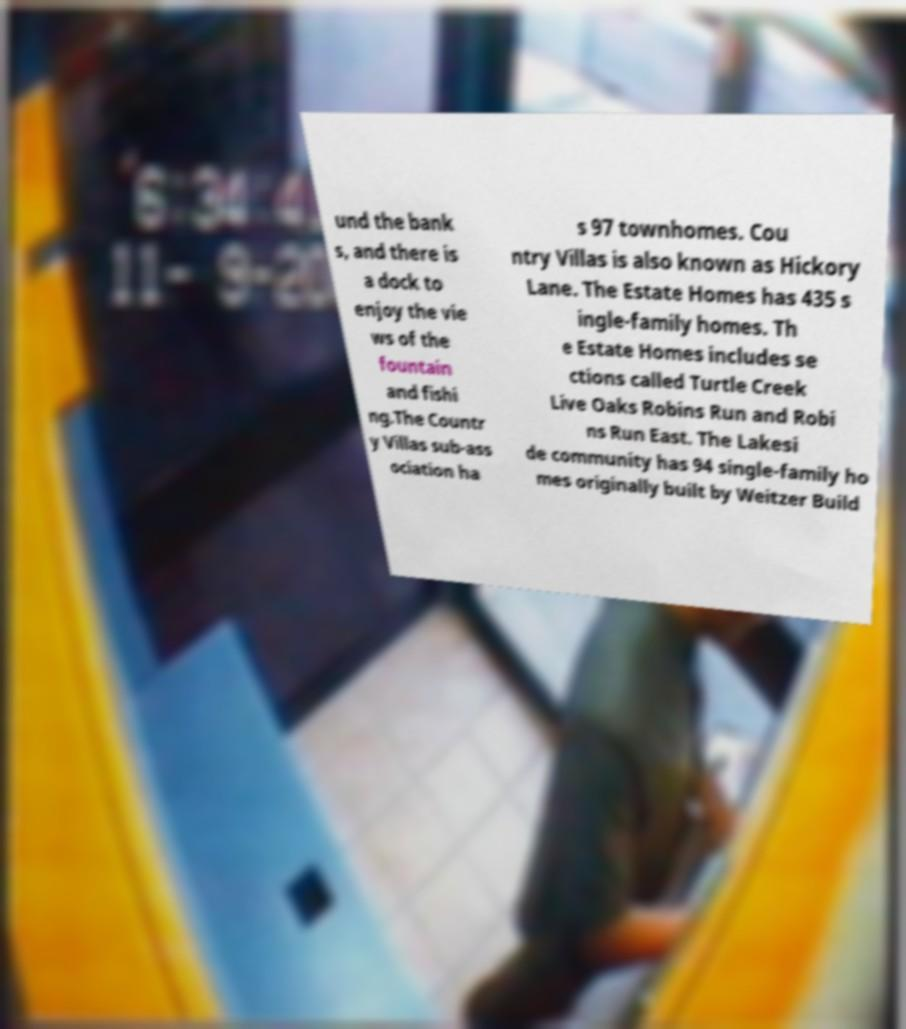There's text embedded in this image that I need extracted. Can you transcribe it verbatim? und the bank s, and there is a dock to enjoy the vie ws of the fountain and fishi ng.The Countr y Villas sub-ass ociation ha s 97 townhomes. Cou ntry Villas is also known as Hickory Lane. The Estate Homes has 435 s ingle-family homes. Th e Estate Homes includes se ctions called Turtle Creek Live Oaks Robins Run and Robi ns Run East. The Lakesi de community has 94 single-family ho mes originally built by Weitzer Build 